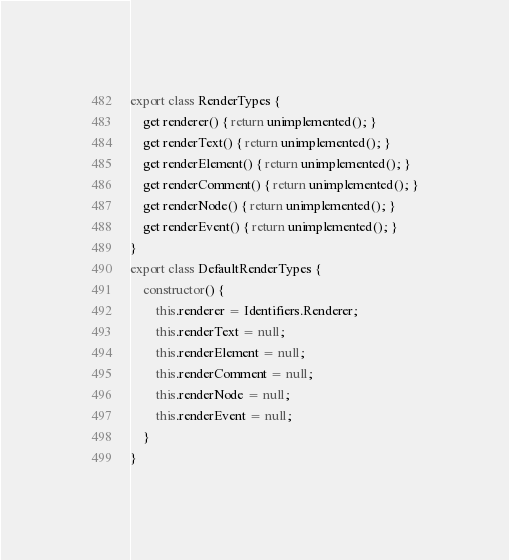Convert code to text. <code><loc_0><loc_0><loc_500><loc_500><_JavaScript_>export class RenderTypes {
    get renderer() { return unimplemented(); }
    get renderText() { return unimplemented(); }
    get renderElement() { return unimplemented(); }
    get renderComment() { return unimplemented(); }
    get renderNode() { return unimplemented(); }
    get renderEvent() { return unimplemented(); }
}
export class DefaultRenderTypes {
    constructor() {
        this.renderer = Identifiers.Renderer;
        this.renderText = null;
        this.renderElement = null;
        this.renderComment = null;
        this.renderNode = null;
        this.renderEvent = null;
    }
}
</code> 